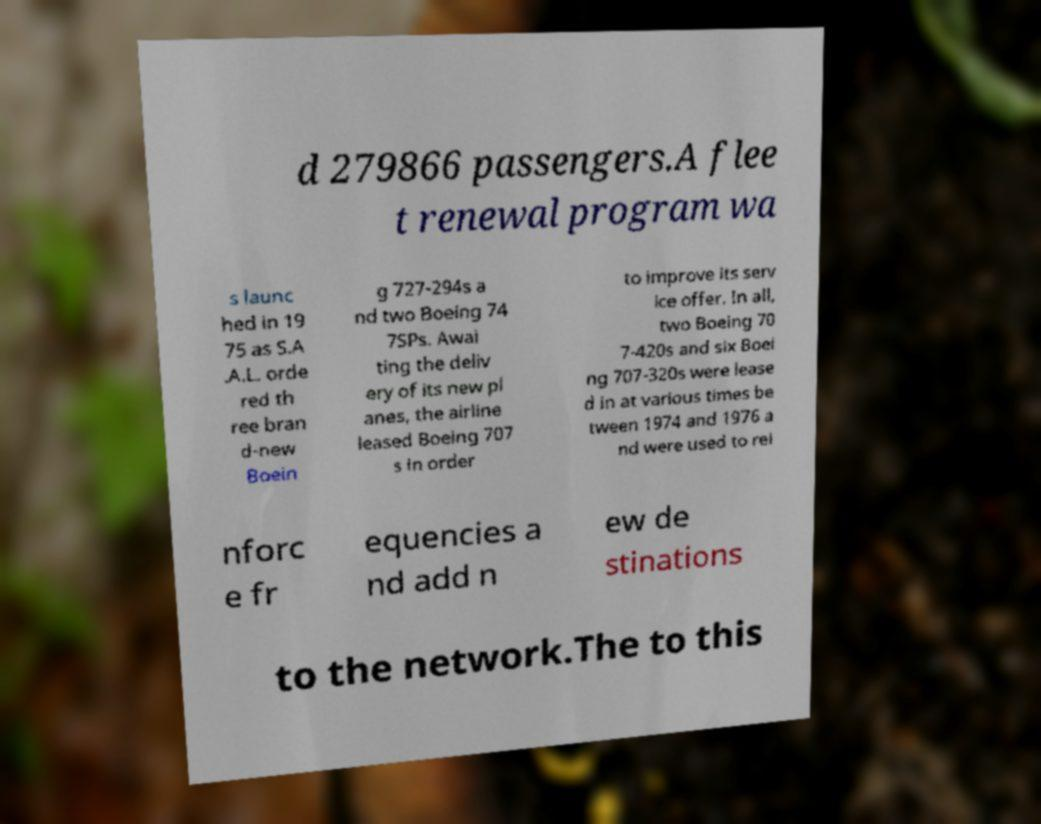What messages or text are displayed in this image? I need them in a readable, typed format. d 279866 passengers.A flee t renewal program wa s launc hed in 19 75 as S.A .A.L. orde red th ree bran d-new Boein g 727-294s a nd two Boeing 74 7SPs. Awai ting the deliv ery of its new pl anes, the airline leased Boeing 707 s in order to improve its serv ice offer. In all, two Boeing 70 7-420s and six Boei ng 707-320s were lease d in at various times be tween 1974 and 1976 a nd were used to rei nforc e fr equencies a nd add n ew de stinations to the network.The to this 